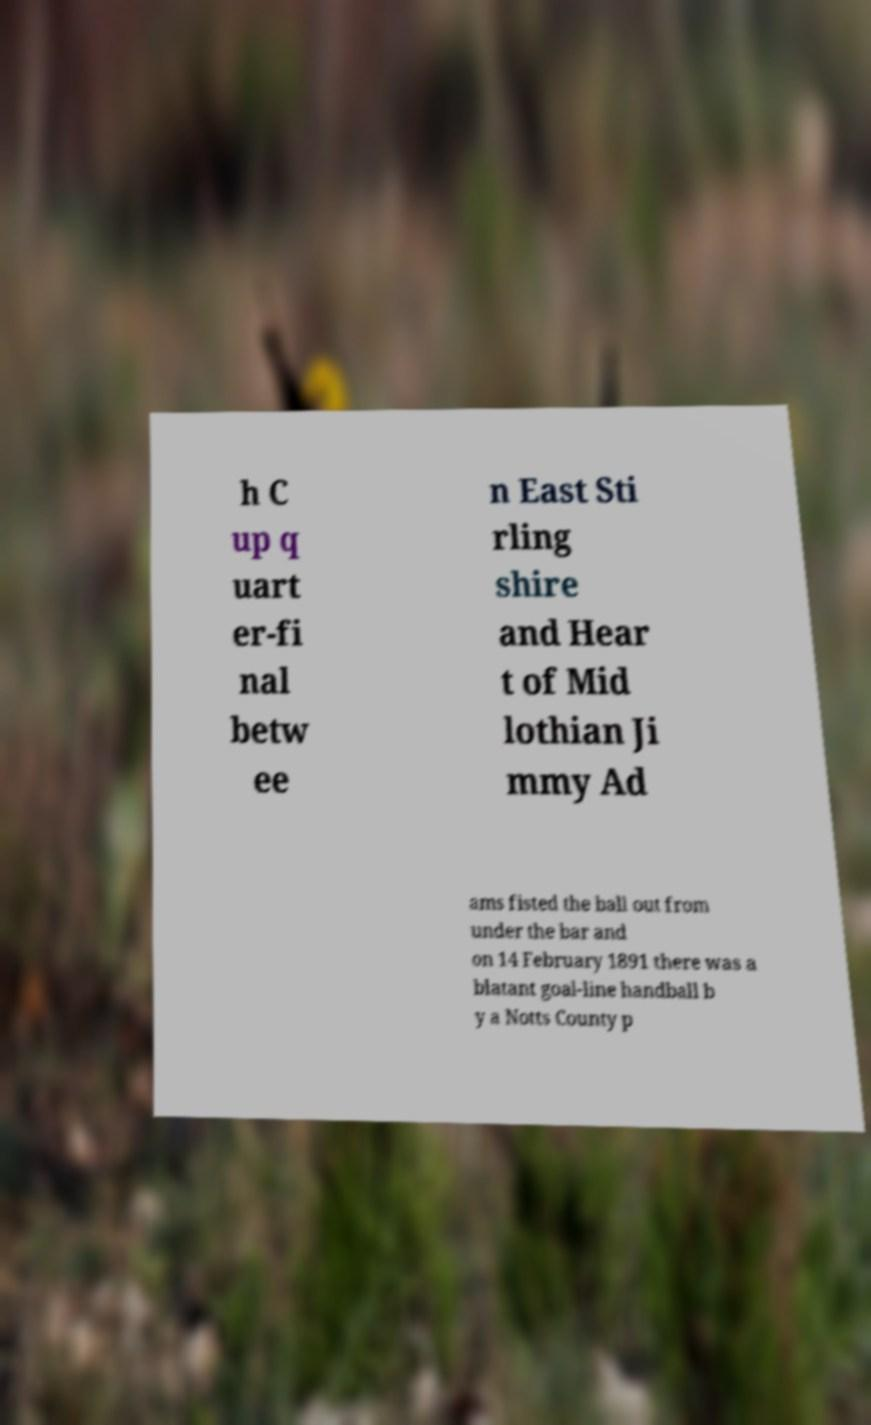Could you extract and type out the text from this image? h C up q uart er-fi nal betw ee n East Sti rling shire and Hear t of Mid lothian Ji mmy Ad ams fisted the ball out from under the bar and on 14 February 1891 there was a blatant goal-line handball b y a Notts County p 